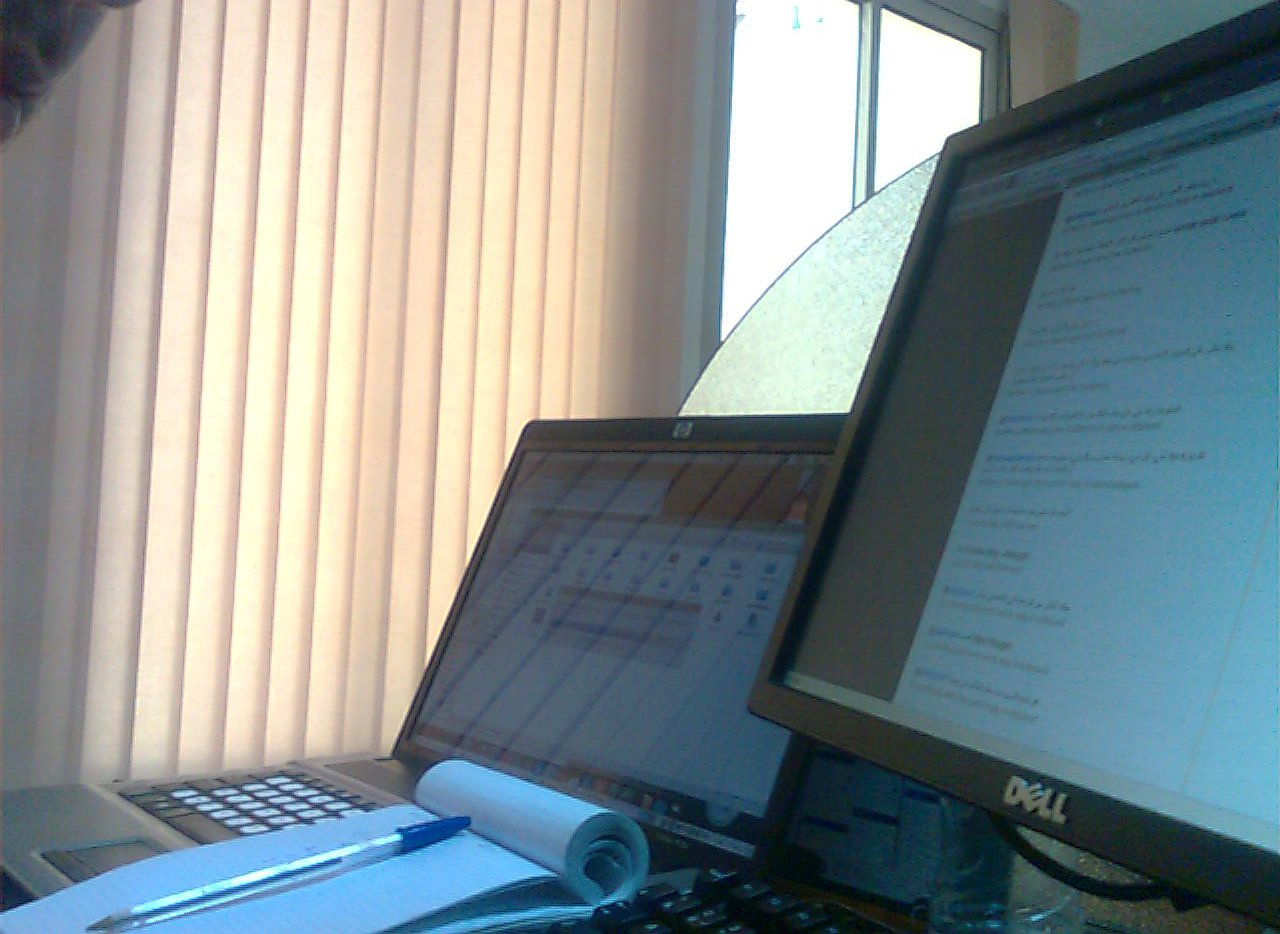In which part is the notepad, the bottom or the top? The notepad is located towards the bottom of the workspace, under other items. 